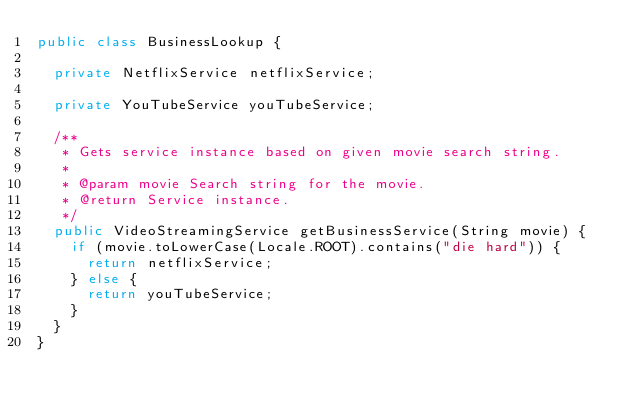Convert code to text. <code><loc_0><loc_0><loc_500><loc_500><_Java_>public class BusinessLookup {

  private NetflixService netflixService;

  private YouTubeService youTubeService;

  /**
   * Gets service instance based on given movie search string.
   *
   * @param movie Search string for the movie.
   * @return Service instance.
   */
  public VideoStreamingService getBusinessService(String movie) {
    if (movie.toLowerCase(Locale.ROOT).contains("die hard")) {
      return netflixService;
    } else {
      return youTubeService;
    }
  }
}
</code> 